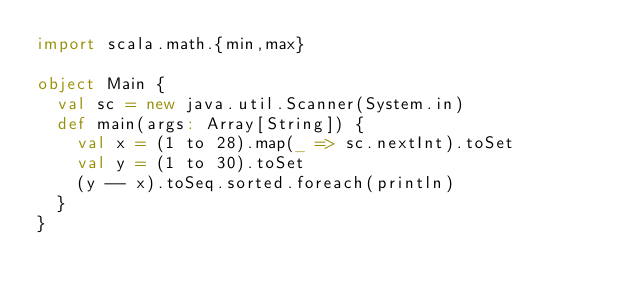<code> <loc_0><loc_0><loc_500><loc_500><_Scala_>import scala.math.{min,max}

object Main {
  val sc = new java.util.Scanner(System.in)
  def main(args: Array[String]) {
    val x = (1 to 28).map(_ => sc.nextInt).toSet
    val y = (1 to 30).toSet
    (y -- x).toSeq.sorted.foreach(println)
  }
}</code> 